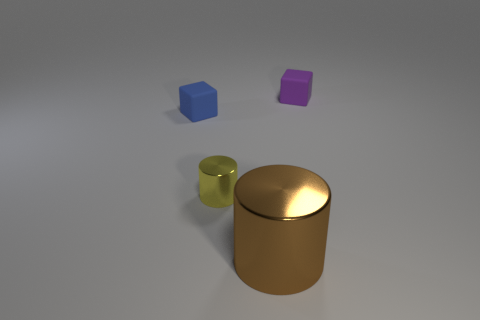The object that is the same material as the tiny cylinder is what color?
Your response must be concise. Brown. What number of matte things are large cylinders or tiny yellow cylinders?
Your answer should be very brief. 0. There is a purple matte thing that is the same size as the yellow metal cylinder; what shape is it?
Offer a very short reply. Cube. How many things are objects that are on the right side of the small yellow object or matte cubes on the right side of the brown shiny cylinder?
Your answer should be compact. 2. There is another cube that is the same size as the purple rubber cube; what is it made of?
Give a very brief answer. Rubber. How many other objects are the same material as the tiny blue object?
Your answer should be compact. 1. Is the number of big things that are behind the large brown metallic cylinder the same as the number of tiny yellow metallic things that are left of the yellow metal thing?
Make the answer very short. Yes. How many green objects are either small matte cubes or metal things?
Give a very brief answer. 0. Is the color of the large shiny cylinder the same as the small matte thing that is behind the small blue matte block?
Offer a very short reply. No. What number of other things are the same color as the tiny metallic object?
Ensure brevity in your answer.  0. 